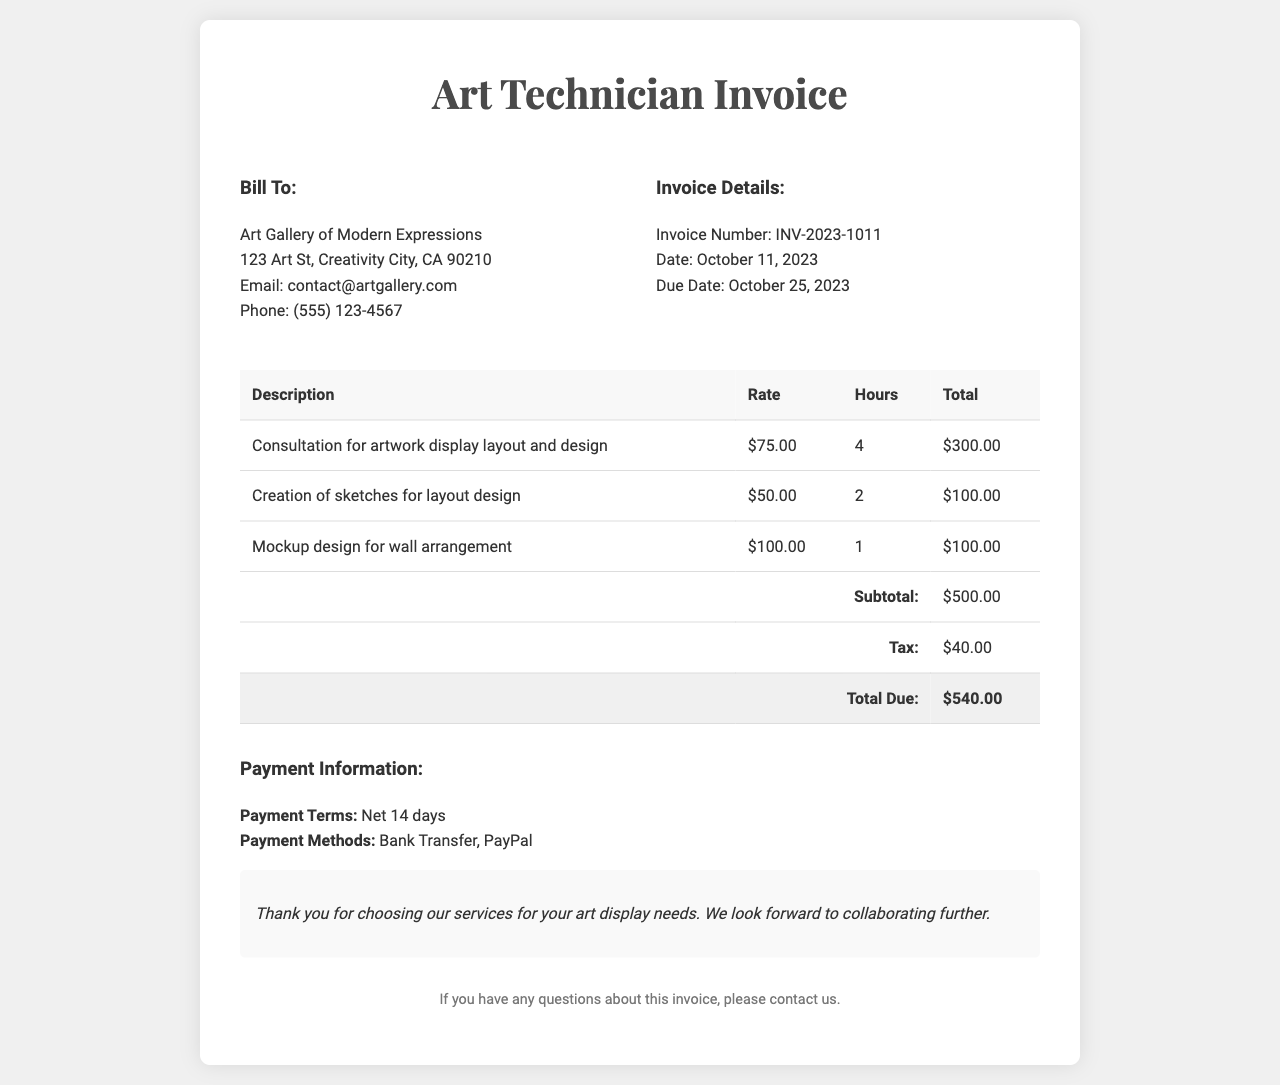What is the invoice number? The invoice number is a unique identifier for the document, listed in the invoice details.
Answer: INV-2023-1011 What is the total amount due? The total amount due is the final amount that needs to be paid, calculated after tax.
Answer: $540.00 What is the rate for consultation services? This rate is listed in the invoice detail for consultation regarding artwork display layout and design.
Answer: $75.00 How many hours were billed for creating sketches? This figure is specified in the table under hours for the corresponding description.
Answer: 2 What is the payment term for this invoice? The payment term indicates the period within which payment should be made, as stated in the payment information.
Answer: Net 14 days What services were provided in this invoice? The services are detailed in the table with descriptions of each service provided along with pricing.
Answer: Consultation for artwork display layout and design, Creation of sketches for layout design, Mockup design for wall arrangement What is the due date for payment? The due date is found in the invoice details section and indicates when payment is expected.
Answer: October 25, 2023 Which payment methods are accepted? This information is indicated under payment information and specifies the methods available for completing the payment.
Answer: Bank Transfer, PayPal What is the subtotal before tax? The subtotal represents the total of services before adding any tax and is provided in the invoice table.
Answer: $500.00 